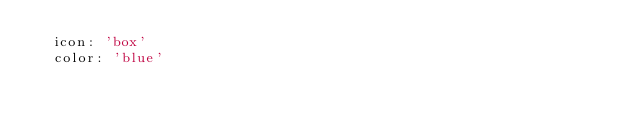Convert code to text. <code><loc_0><loc_0><loc_500><loc_500><_YAML_>  icon: 'box'
  color: 'blue'
</code> 